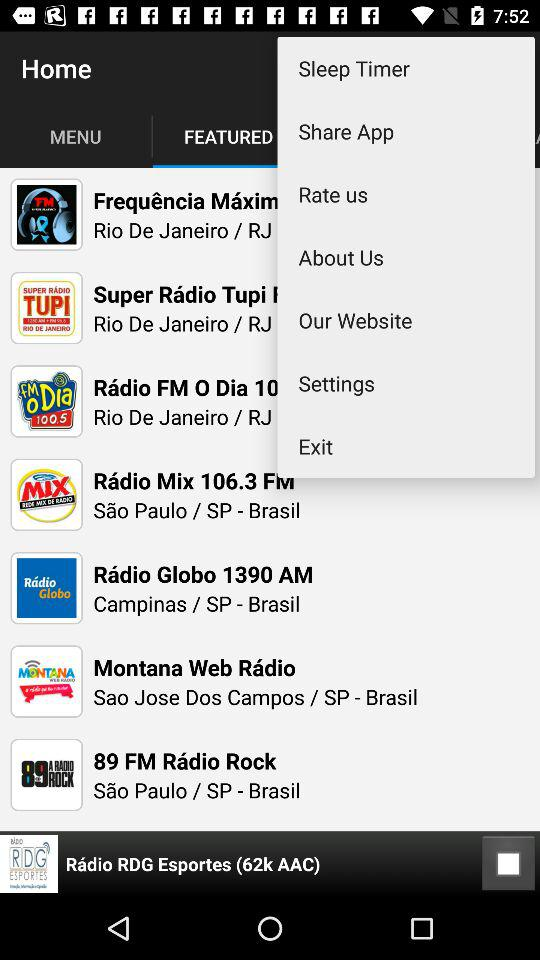What is the size of selected audio?
When the provided information is insufficient, respond with <no answer>. <no answer> 